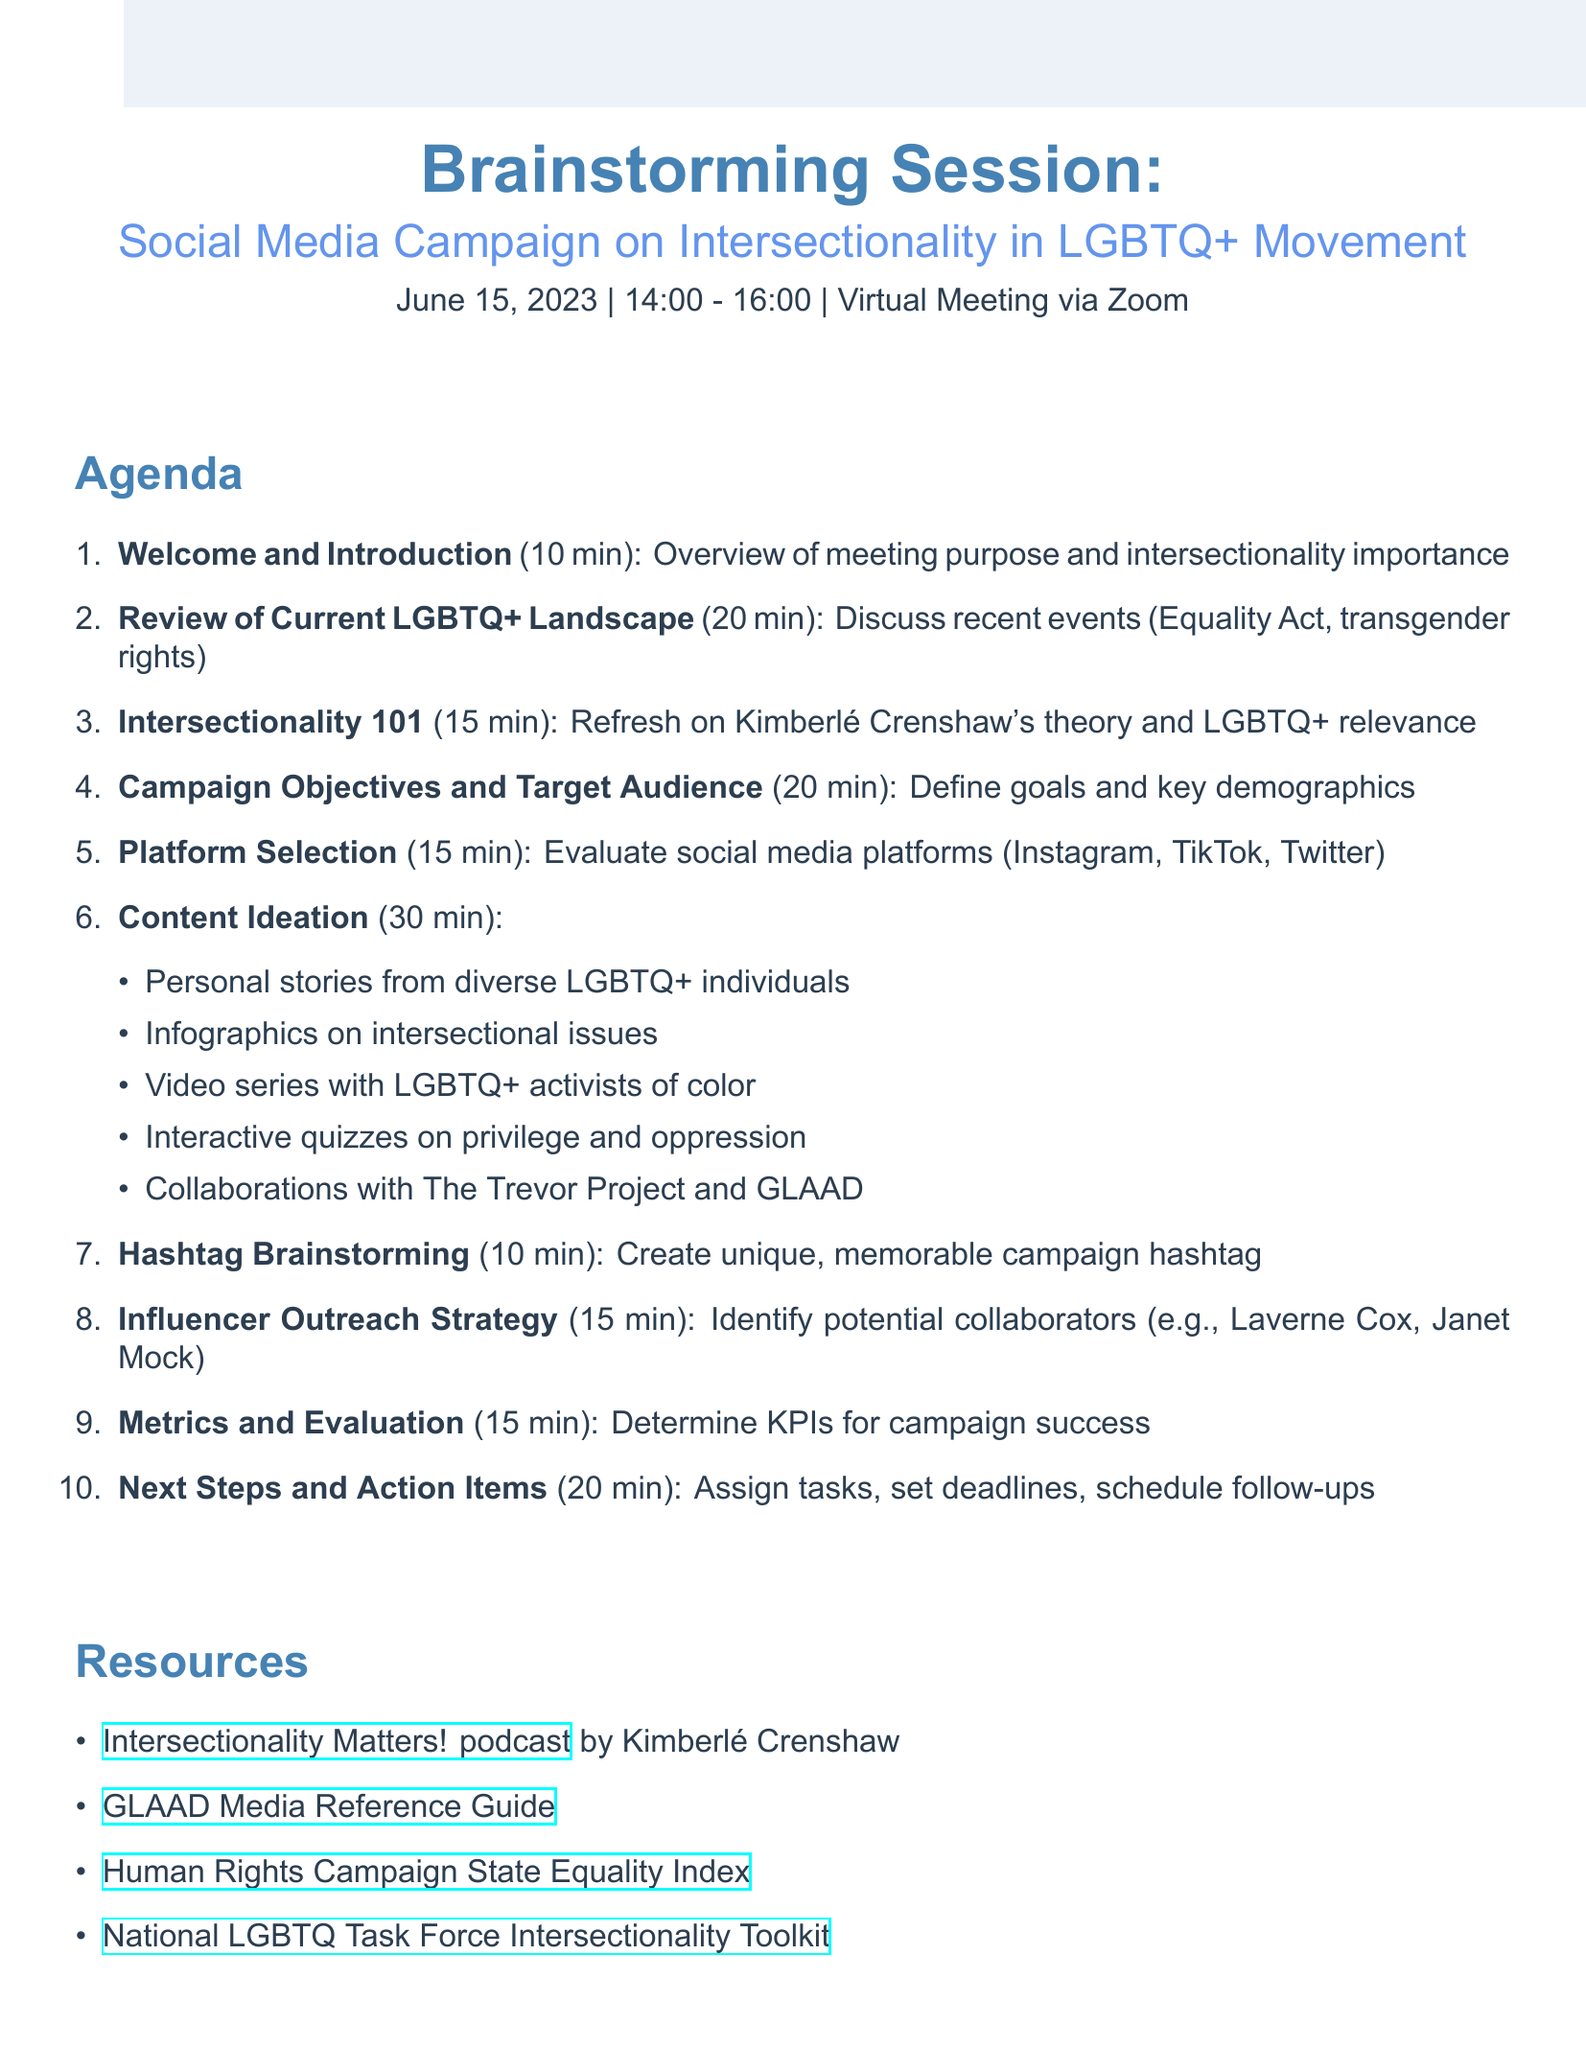What is the date of the meeting? The date of the meeting is clearly stated in the document.
Answer: June 15, 2023 How long is the "Content Ideation" section? The duration of the "Content Ideation" section is specified in the document.
Answer: 30 minutes What is the purpose of the meeting? The document provides an overview of the meeting's purpose including the focus on intersectionality in LGBTQ+ activism.
Answer: Raise awareness about intersectionality Who are some potential collaborators mentioned for influencer outreach? The document lists specific names under the influencer outreach strategy.
Answer: Laverne Cox, Janet Mock, Alok Vaid-Menon What is one resource listed for intersectionality? The document includes various resources, and this asks for just one of them.
Answer: Intersectionality Matters! podcast What is the total duration of the meeting? The document outlines the start and end times of the meeting, which can be used to calculate its total duration.
Answer: 2 hours 